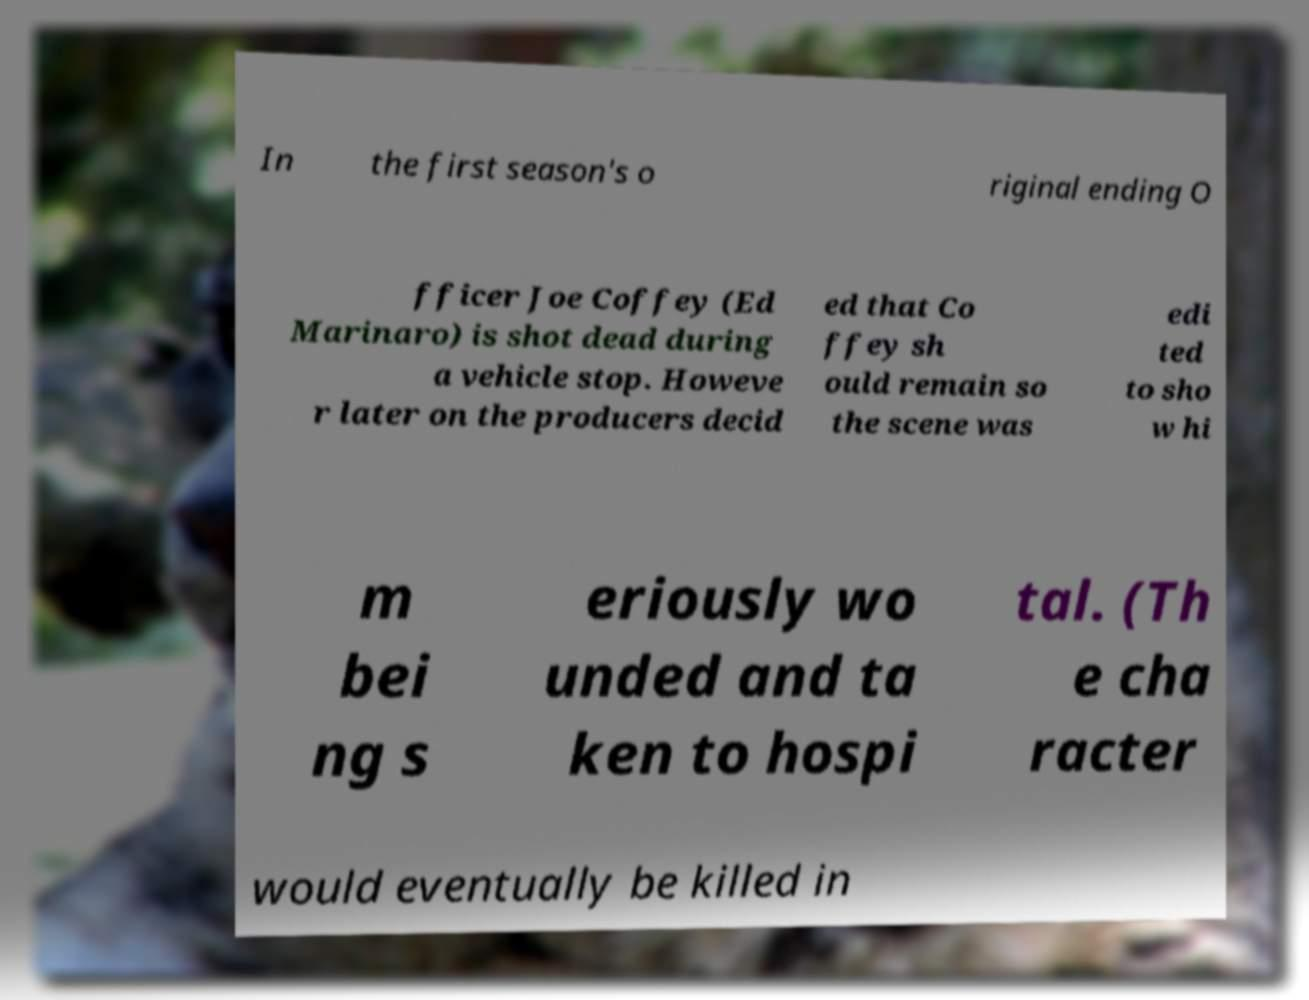Can you accurately transcribe the text from the provided image for me? In the first season's o riginal ending O fficer Joe Coffey (Ed Marinaro) is shot dead during a vehicle stop. Howeve r later on the producers decid ed that Co ffey sh ould remain so the scene was edi ted to sho w hi m bei ng s eriously wo unded and ta ken to hospi tal. (Th e cha racter would eventually be killed in 